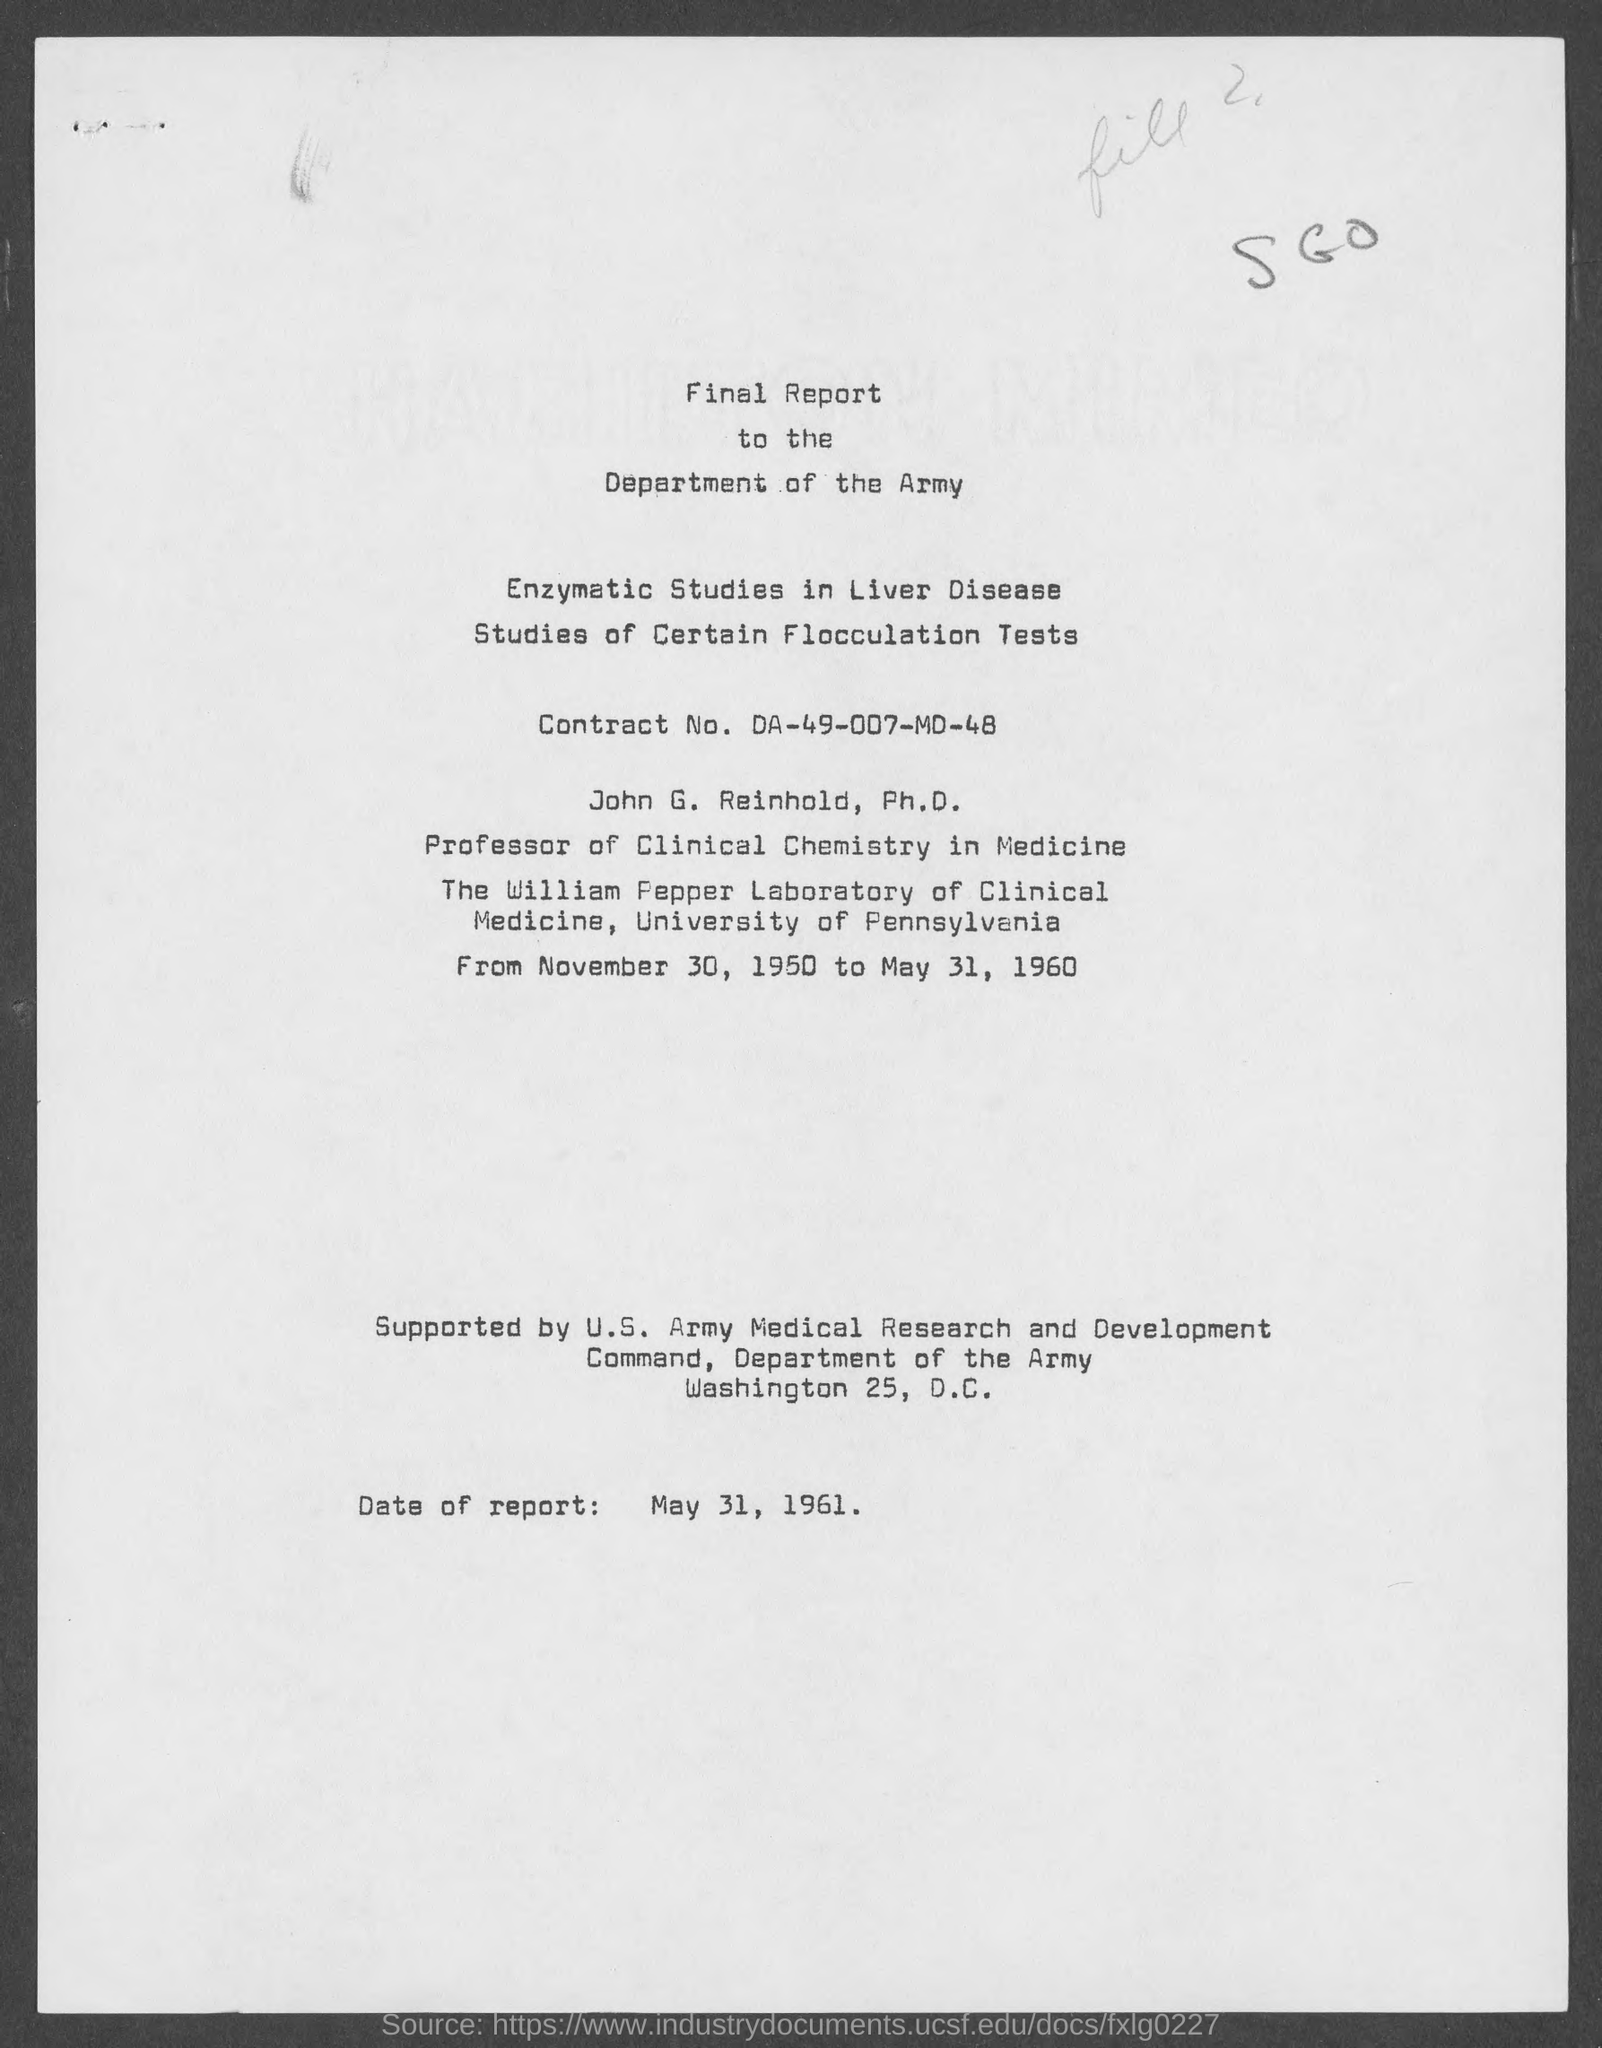Indicate a few pertinent items in this graphic. The document contains information about a report that was created on May 31, 1961. 